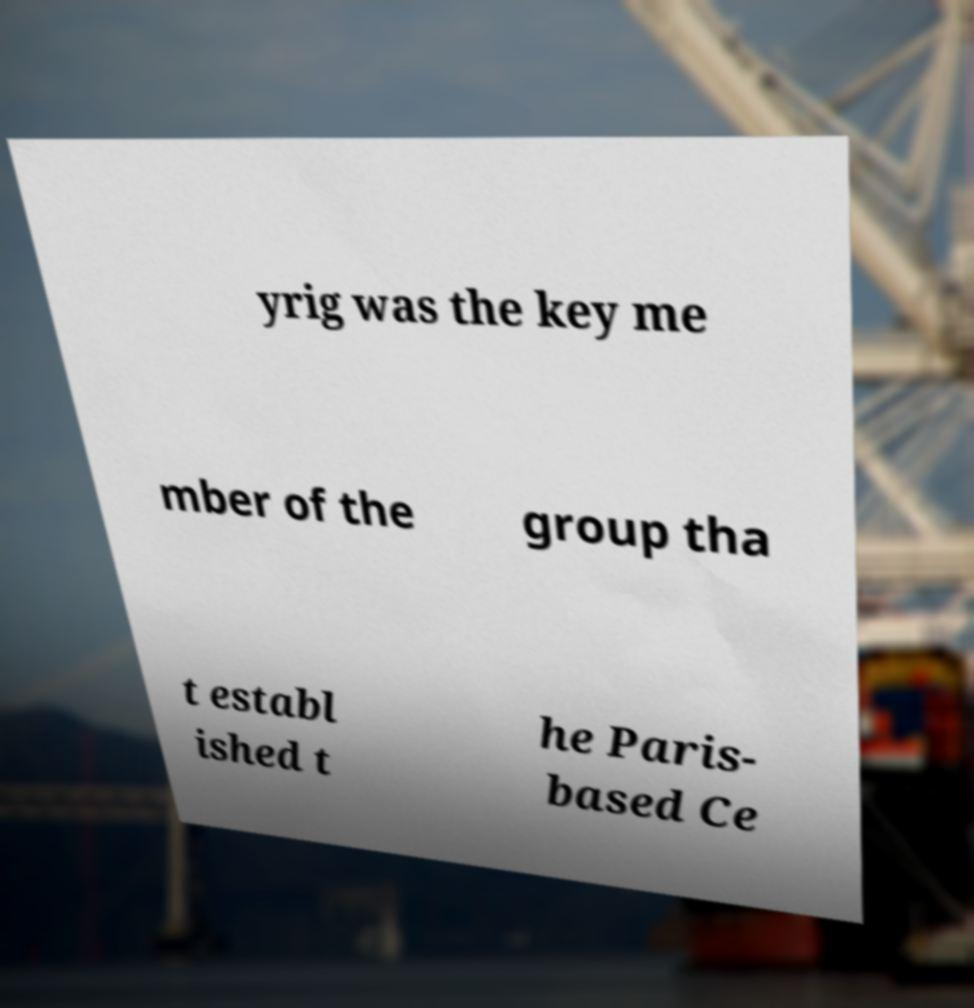Can you read and provide the text displayed in the image?This photo seems to have some interesting text. Can you extract and type it out for me? yrig was the key me mber of the group tha t establ ished t he Paris- based Ce 